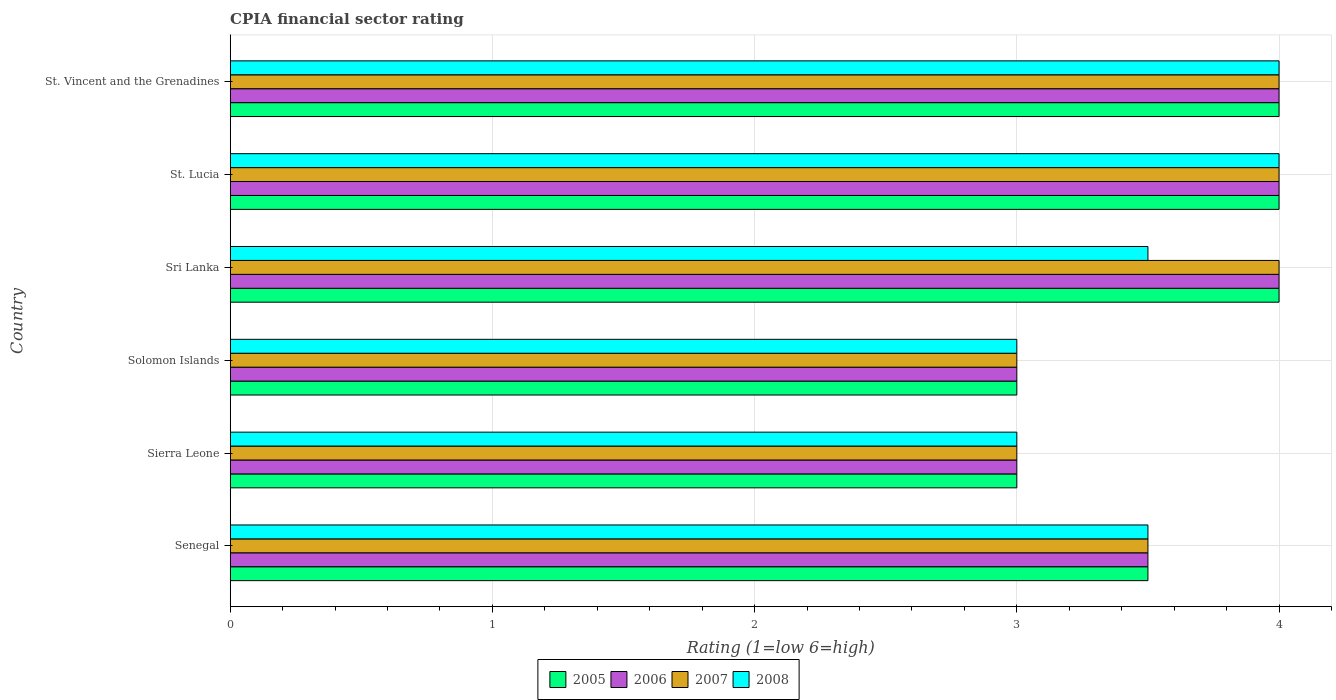How many different coloured bars are there?
Your answer should be very brief. 4. Are the number of bars per tick equal to the number of legend labels?
Ensure brevity in your answer.  Yes. What is the label of the 2nd group of bars from the top?
Provide a short and direct response. St. Lucia. Across all countries, what is the minimum CPIA rating in 2005?
Your response must be concise. 3. In which country was the CPIA rating in 2008 maximum?
Make the answer very short. St. Lucia. In which country was the CPIA rating in 2007 minimum?
Provide a short and direct response. Sierra Leone. What is the total CPIA rating in 2007 in the graph?
Ensure brevity in your answer.  21.5. What is the difference between the CPIA rating in 2007 in Sierra Leone and that in Sri Lanka?
Provide a short and direct response. -1. What is the average CPIA rating in 2008 per country?
Your answer should be very brief. 3.5. What is the difference between the highest and the lowest CPIA rating in 2005?
Your response must be concise. 1. In how many countries, is the CPIA rating in 2007 greater than the average CPIA rating in 2007 taken over all countries?
Provide a succinct answer. 3. What does the 2nd bar from the top in Sri Lanka represents?
Give a very brief answer. 2007. Are all the bars in the graph horizontal?
Your answer should be very brief. Yes. Are the values on the major ticks of X-axis written in scientific E-notation?
Make the answer very short. No. Does the graph contain grids?
Your answer should be very brief. Yes. How many legend labels are there?
Ensure brevity in your answer.  4. How are the legend labels stacked?
Your answer should be compact. Horizontal. What is the title of the graph?
Provide a succinct answer. CPIA financial sector rating. Does "1972" appear as one of the legend labels in the graph?
Your response must be concise. No. What is the label or title of the X-axis?
Provide a succinct answer. Rating (1=low 6=high). What is the label or title of the Y-axis?
Keep it short and to the point. Country. What is the Rating (1=low 6=high) in 2005 in Sierra Leone?
Make the answer very short. 3. What is the Rating (1=low 6=high) in 2007 in Sierra Leone?
Give a very brief answer. 3. What is the Rating (1=low 6=high) in 2008 in Sierra Leone?
Keep it short and to the point. 3. What is the Rating (1=low 6=high) in 2005 in Solomon Islands?
Make the answer very short. 3. What is the Rating (1=low 6=high) of 2005 in Sri Lanka?
Provide a short and direct response. 4. What is the Rating (1=low 6=high) in 2006 in Sri Lanka?
Provide a succinct answer. 4. What is the Rating (1=low 6=high) in 2007 in Sri Lanka?
Keep it short and to the point. 4. What is the Rating (1=low 6=high) of 2006 in St. Lucia?
Your answer should be compact. 4. What is the Rating (1=low 6=high) of 2005 in St. Vincent and the Grenadines?
Keep it short and to the point. 4. What is the Rating (1=low 6=high) in 2006 in St. Vincent and the Grenadines?
Keep it short and to the point. 4. What is the Rating (1=low 6=high) in 2008 in St. Vincent and the Grenadines?
Offer a very short reply. 4. Across all countries, what is the maximum Rating (1=low 6=high) of 2005?
Give a very brief answer. 4. Across all countries, what is the maximum Rating (1=low 6=high) in 2006?
Your response must be concise. 4. Across all countries, what is the maximum Rating (1=low 6=high) of 2007?
Your answer should be compact. 4. Across all countries, what is the minimum Rating (1=low 6=high) in 2006?
Your response must be concise. 3. What is the total Rating (1=low 6=high) of 2006 in the graph?
Give a very brief answer. 21.5. What is the total Rating (1=low 6=high) of 2007 in the graph?
Ensure brevity in your answer.  21.5. What is the difference between the Rating (1=low 6=high) in 2005 in Senegal and that in Solomon Islands?
Make the answer very short. 0.5. What is the difference between the Rating (1=low 6=high) in 2007 in Senegal and that in Solomon Islands?
Your answer should be compact. 0.5. What is the difference between the Rating (1=low 6=high) in 2008 in Senegal and that in Solomon Islands?
Make the answer very short. 0.5. What is the difference between the Rating (1=low 6=high) of 2005 in Senegal and that in Sri Lanka?
Offer a very short reply. -0.5. What is the difference between the Rating (1=low 6=high) of 2007 in Senegal and that in Sri Lanka?
Give a very brief answer. -0.5. What is the difference between the Rating (1=low 6=high) of 2005 in Senegal and that in St. Lucia?
Offer a terse response. -0.5. What is the difference between the Rating (1=low 6=high) in 2007 in Senegal and that in St. Lucia?
Make the answer very short. -0.5. What is the difference between the Rating (1=low 6=high) in 2008 in Senegal and that in St. Lucia?
Provide a short and direct response. -0.5. What is the difference between the Rating (1=low 6=high) in 2005 in Sierra Leone and that in Solomon Islands?
Offer a very short reply. 0. What is the difference between the Rating (1=low 6=high) in 2006 in Sierra Leone and that in Solomon Islands?
Provide a short and direct response. 0. What is the difference between the Rating (1=low 6=high) of 2007 in Sierra Leone and that in Solomon Islands?
Keep it short and to the point. 0. What is the difference between the Rating (1=low 6=high) in 2005 in Sierra Leone and that in Sri Lanka?
Keep it short and to the point. -1. What is the difference between the Rating (1=low 6=high) in 2006 in Sierra Leone and that in Sri Lanka?
Your answer should be compact. -1. What is the difference between the Rating (1=low 6=high) in 2007 in Sierra Leone and that in Sri Lanka?
Your response must be concise. -1. What is the difference between the Rating (1=low 6=high) in 2008 in Sierra Leone and that in Sri Lanka?
Your response must be concise. -0.5. What is the difference between the Rating (1=low 6=high) in 2005 in Sierra Leone and that in St. Vincent and the Grenadines?
Ensure brevity in your answer.  -1. What is the difference between the Rating (1=low 6=high) in 2007 in Sierra Leone and that in St. Vincent and the Grenadines?
Offer a very short reply. -1. What is the difference between the Rating (1=low 6=high) of 2005 in Solomon Islands and that in Sri Lanka?
Keep it short and to the point. -1. What is the difference between the Rating (1=low 6=high) of 2008 in Solomon Islands and that in Sri Lanka?
Offer a terse response. -0.5. What is the difference between the Rating (1=low 6=high) in 2005 in Solomon Islands and that in St. Lucia?
Your answer should be compact. -1. What is the difference between the Rating (1=low 6=high) of 2007 in Solomon Islands and that in St. Lucia?
Keep it short and to the point. -1. What is the difference between the Rating (1=low 6=high) in 2008 in Solomon Islands and that in St. Lucia?
Your response must be concise. -1. What is the difference between the Rating (1=low 6=high) of 2008 in Sri Lanka and that in St. Lucia?
Give a very brief answer. -0.5. What is the difference between the Rating (1=low 6=high) in 2006 in Sri Lanka and that in St. Vincent and the Grenadines?
Provide a short and direct response. 0. What is the difference between the Rating (1=low 6=high) in 2005 in St. Lucia and that in St. Vincent and the Grenadines?
Ensure brevity in your answer.  0. What is the difference between the Rating (1=low 6=high) in 2008 in St. Lucia and that in St. Vincent and the Grenadines?
Your response must be concise. 0. What is the difference between the Rating (1=low 6=high) in 2005 in Senegal and the Rating (1=low 6=high) in 2007 in Sierra Leone?
Provide a short and direct response. 0.5. What is the difference between the Rating (1=low 6=high) in 2006 in Senegal and the Rating (1=low 6=high) in 2007 in Sierra Leone?
Your response must be concise. 0.5. What is the difference between the Rating (1=low 6=high) of 2007 in Senegal and the Rating (1=low 6=high) of 2008 in Sierra Leone?
Your answer should be compact. 0.5. What is the difference between the Rating (1=low 6=high) in 2005 in Senegal and the Rating (1=low 6=high) in 2008 in Solomon Islands?
Your response must be concise. 0.5. What is the difference between the Rating (1=low 6=high) of 2007 in Senegal and the Rating (1=low 6=high) of 2008 in Solomon Islands?
Keep it short and to the point. 0.5. What is the difference between the Rating (1=low 6=high) in 2005 in Senegal and the Rating (1=low 6=high) in 2006 in St. Lucia?
Offer a terse response. -0.5. What is the difference between the Rating (1=low 6=high) of 2005 in Senegal and the Rating (1=low 6=high) of 2008 in St. Lucia?
Offer a very short reply. -0.5. What is the difference between the Rating (1=low 6=high) in 2006 in Senegal and the Rating (1=low 6=high) in 2008 in St. Lucia?
Provide a short and direct response. -0.5. What is the difference between the Rating (1=low 6=high) in 2007 in Senegal and the Rating (1=low 6=high) in 2008 in St. Lucia?
Offer a terse response. -0.5. What is the difference between the Rating (1=low 6=high) in 2005 in Senegal and the Rating (1=low 6=high) in 2006 in St. Vincent and the Grenadines?
Keep it short and to the point. -0.5. What is the difference between the Rating (1=low 6=high) of 2005 in Senegal and the Rating (1=low 6=high) of 2007 in St. Vincent and the Grenadines?
Your response must be concise. -0.5. What is the difference between the Rating (1=low 6=high) of 2005 in Senegal and the Rating (1=low 6=high) of 2008 in St. Vincent and the Grenadines?
Your response must be concise. -0.5. What is the difference between the Rating (1=low 6=high) of 2006 in Senegal and the Rating (1=low 6=high) of 2007 in St. Vincent and the Grenadines?
Provide a short and direct response. -0.5. What is the difference between the Rating (1=low 6=high) in 2006 in Senegal and the Rating (1=low 6=high) in 2008 in St. Vincent and the Grenadines?
Your response must be concise. -0.5. What is the difference between the Rating (1=low 6=high) in 2007 in Senegal and the Rating (1=low 6=high) in 2008 in St. Vincent and the Grenadines?
Provide a short and direct response. -0.5. What is the difference between the Rating (1=low 6=high) in 2007 in Sierra Leone and the Rating (1=low 6=high) in 2008 in Solomon Islands?
Give a very brief answer. 0. What is the difference between the Rating (1=low 6=high) in 2005 in Sierra Leone and the Rating (1=low 6=high) in 2007 in Sri Lanka?
Provide a succinct answer. -1. What is the difference between the Rating (1=low 6=high) of 2006 in Sierra Leone and the Rating (1=low 6=high) of 2007 in Sri Lanka?
Keep it short and to the point. -1. What is the difference between the Rating (1=low 6=high) in 2006 in Sierra Leone and the Rating (1=low 6=high) in 2008 in Sri Lanka?
Keep it short and to the point. -0.5. What is the difference between the Rating (1=low 6=high) of 2007 in Sierra Leone and the Rating (1=low 6=high) of 2008 in Sri Lanka?
Give a very brief answer. -0.5. What is the difference between the Rating (1=low 6=high) in 2006 in Sierra Leone and the Rating (1=low 6=high) in 2007 in St. Lucia?
Your answer should be compact. -1. What is the difference between the Rating (1=low 6=high) of 2006 in Sierra Leone and the Rating (1=low 6=high) of 2008 in St. Lucia?
Ensure brevity in your answer.  -1. What is the difference between the Rating (1=low 6=high) of 2007 in Sierra Leone and the Rating (1=low 6=high) of 2008 in St. Lucia?
Offer a very short reply. -1. What is the difference between the Rating (1=low 6=high) in 2006 in Sierra Leone and the Rating (1=low 6=high) in 2007 in St. Vincent and the Grenadines?
Keep it short and to the point. -1. What is the difference between the Rating (1=low 6=high) in 2006 in Sierra Leone and the Rating (1=low 6=high) in 2008 in St. Vincent and the Grenadines?
Your answer should be very brief. -1. What is the difference between the Rating (1=low 6=high) of 2005 in Solomon Islands and the Rating (1=low 6=high) of 2007 in Sri Lanka?
Make the answer very short. -1. What is the difference between the Rating (1=low 6=high) of 2005 in Solomon Islands and the Rating (1=low 6=high) of 2008 in Sri Lanka?
Offer a terse response. -0.5. What is the difference between the Rating (1=low 6=high) in 2006 in Solomon Islands and the Rating (1=low 6=high) in 2007 in Sri Lanka?
Keep it short and to the point. -1. What is the difference between the Rating (1=low 6=high) of 2007 in Solomon Islands and the Rating (1=low 6=high) of 2008 in Sri Lanka?
Offer a terse response. -0.5. What is the difference between the Rating (1=low 6=high) of 2006 in Solomon Islands and the Rating (1=low 6=high) of 2007 in St. Lucia?
Keep it short and to the point. -1. What is the difference between the Rating (1=low 6=high) of 2007 in Solomon Islands and the Rating (1=low 6=high) of 2008 in St. Lucia?
Your answer should be compact. -1. What is the difference between the Rating (1=low 6=high) of 2005 in Solomon Islands and the Rating (1=low 6=high) of 2006 in St. Vincent and the Grenadines?
Your answer should be compact. -1. What is the difference between the Rating (1=low 6=high) of 2005 in Solomon Islands and the Rating (1=low 6=high) of 2007 in St. Vincent and the Grenadines?
Give a very brief answer. -1. What is the difference between the Rating (1=low 6=high) of 2006 in Solomon Islands and the Rating (1=low 6=high) of 2008 in St. Vincent and the Grenadines?
Provide a short and direct response. -1. What is the difference between the Rating (1=low 6=high) in 2005 in Sri Lanka and the Rating (1=low 6=high) in 2006 in St. Lucia?
Your answer should be very brief. 0. What is the difference between the Rating (1=low 6=high) of 2006 in Sri Lanka and the Rating (1=low 6=high) of 2007 in St. Lucia?
Ensure brevity in your answer.  0. What is the difference between the Rating (1=low 6=high) of 2005 in Sri Lanka and the Rating (1=low 6=high) of 2006 in St. Vincent and the Grenadines?
Keep it short and to the point. 0. What is the difference between the Rating (1=low 6=high) in 2005 in Sri Lanka and the Rating (1=low 6=high) in 2008 in St. Vincent and the Grenadines?
Keep it short and to the point. 0. What is the difference between the Rating (1=low 6=high) in 2006 in Sri Lanka and the Rating (1=low 6=high) in 2007 in St. Vincent and the Grenadines?
Offer a very short reply. 0. What is the difference between the Rating (1=low 6=high) in 2005 in St. Lucia and the Rating (1=low 6=high) in 2007 in St. Vincent and the Grenadines?
Your answer should be compact. 0. What is the difference between the Rating (1=low 6=high) in 2005 in St. Lucia and the Rating (1=low 6=high) in 2008 in St. Vincent and the Grenadines?
Give a very brief answer. 0. What is the difference between the Rating (1=low 6=high) in 2006 in St. Lucia and the Rating (1=low 6=high) in 2007 in St. Vincent and the Grenadines?
Offer a very short reply. 0. What is the average Rating (1=low 6=high) in 2005 per country?
Your response must be concise. 3.58. What is the average Rating (1=low 6=high) in 2006 per country?
Your answer should be compact. 3.58. What is the average Rating (1=low 6=high) in 2007 per country?
Provide a short and direct response. 3.58. What is the average Rating (1=low 6=high) of 2008 per country?
Keep it short and to the point. 3.5. What is the difference between the Rating (1=low 6=high) of 2005 and Rating (1=low 6=high) of 2006 in Senegal?
Provide a short and direct response. 0. What is the difference between the Rating (1=low 6=high) of 2005 and Rating (1=low 6=high) of 2008 in Senegal?
Give a very brief answer. 0. What is the difference between the Rating (1=low 6=high) of 2006 and Rating (1=low 6=high) of 2008 in Senegal?
Make the answer very short. 0. What is the difference between the Rating (1=low 6=high) in 2007 and Rating (1=low 6=high) in 2008 in Senegal?
Keep it short and to the point. 0. What is the difference between the Rating (1=low 6=high) in 2005 and Rating (1=low 6=high) in 2006 in Sierra Leone?
Provide a succinct answer. 0. What is the difference between the Rating (1=low 6=high) in 2006 and Rating (1=low 6=high) in 2008 in Sierra Leone?
Make the answer very short. 0. What is the difference between the Rating (1=low 6=high) in 2007 and Rating (1=low 6=high) in 2008 in Sierra Leone?
Give a very brief answer. 0. What is the difference between the Rating (1=low 6=high) of 2005 and Rating (1=low 6=high) of 2006 in Solomon Islands?
Offer a terse response. 0. What is the difference between the Rating (1=low 6=high) in 2006 and Rating (1=low 6=high) in 2007 in Solomon Islands?
Ensure brevity in your answer.  0. What is the difference between the Rating (1=low 6=high) of 2007 and Rating (1=low 6=high) of 2008 in Solomon Islands?
Your response must be concise. 0. What is the difference between the Rating (1=low 6=high) in 2005 and Rating (1=low 6=high) in 2008 in Sri Lanka?
Provide a succinct answer. 0.5. What is the difference between the Rating (1=low 6=high) in 2006 and Rating (1=low 6=high) in 2008 in Sri Lanka?
Offer a terse response. 0.5. What is the difference between the Rating (1=low 6=high) of 2005 and Rating (1=low 6=high) of 2006 in St. Lucia?
Your response must be concise. 0. What is the difference between the Rating (1=low 6=high) in 2005 and Rating (1=low 6=high) in 2007 in St. Vincent and the Grenadines?
Provide a short and direct response. 0. What is the difference between the Rating (1=low 6=high) of 2005 and Rating (1=low 6=high) of 2008 in St. Vincent and the Grenadines?
Your response must be concise. 0. What is the ratio of the Rating (1=low 6=high) in 2006 in Senegal to that in Sierra Leone?
Provide a succinct answer. 1.17. What is the ratio of the Rating (1=low 6=high) in 2007 in Senegal to that in Sierra Leone?
Provide a short and direct response. 1.17. What is the ratio of the Rating (1=low 6=high) in 2008 in Senegal to that in Sierra Leone?
Provide a succinct answer. 1.17. What is the ratio of the Rating (1=low 6=high) in 2005 in Senegal to that in Solomon Islands?
Your response must be concise. 1.17. What is the ratio of the Rating (1=low 6=high) of 2006 in Senegal to that in Solomon Islands?
Keep it short and to the point. 1.17. What is the ratio of the Rating (1=low 6=high) in 2007 in Senegal to that in Solomon Islands?
Make the answer very short. 1.17. What is the ratio of the Rating (1=low 6=high) in 2008 in Senegal to that in Solomon Islands?
Provide a succinct answer. 1.17. What is the ratio of the Rating (1=low 6=high) in 2005 in Senegal to that in St. Lucia?
Keep it short and to the point. 0.88. What is the ratio of the Rating (1=low 6=high) of 2006 in Senegal to that in St. Lucia?
Keep it short and to the point. 0.88. What is the ratio of the Rating (1=low 6=high) in 2005 in Senegal to that in St. Vincent and the Grenadines?
Provide a succinct answer. 0.88. What is the ratio of the Rating (1=low 6=high) of 2007 in Senegal to that in St. Vincent and the Grenadines?
Your answer should be compact. 0.88. What is the ratio of the Rating (1=low 6=high) in 2005 in Sierra Leone to that in Solomon Islands?
Keep it short and to the point. 1. What is the ratio of the Rating (1=low 6=high) of 2005 in Sierra Leone to that in Sri Lanka?
Offer a very short reply. 0.75. What is the ratio of the Rating (1=low 6=high) in 2006 in Sierra Leone to that in Sri Lanka?
Offer a terse response. 0.75. What is the ratio of the Rating (1=low 6=high) of 2006 in Sierra Leone to that in St. Lucia?
Provide a succinct answer. 0.75. What is the ratio of the Rating (1=low 6=high) in 2007 in Sierra Leone to that in St. Lucia?
Provide a short and direct response. 0.75. What is the ratio of the Rating (1=low 6=high) of 2006 in Sierra Leone to that in St. Vincent and the Grenadines?
Provide a succinct answer. 0.75. What is the ratio of the Rating (1=low 6=high) of 2008 in Solomon Islands to that in Sri Lanka?
Offer a very short reply. 0.86. What is the ratio of the Rating (1=low 6=high) in 2008 in Solomon Islands to that in St. Lucia?
Your answer should be very brief. 0.75. What is the ratio of the Rating (1=low 6=high) of 2005 in Solomon Islands to that in St. Vincent and the Grenadines?
Provide a short and direct response. 0.75. What is the ratio of the Rating (1=low 6=high) of 2008 in Solomon Islands to that in St. Vincent and the Grenadines?
Make the answer very short. 0.75. What is the ratio of the Rating (1=low 6=high) in 2006 in Sri Lanka to that in St. Lucia?
Offer a very short reply. 1. What is the ratio of the Rating (1=low 6=high) of 2005 in Sri Lanka to that in St. Vincent and the Grenadines?
Offer a terse response. 1. What is the ratio of the Rating (1=low 6=high) of 2006 in Sri Lanka to that in St. Vincent and the Grenadines?
Give a very brief answer. 1. What is the ratio of the Rating (1=low 6=high) in 2007 in Sri Lanka to that in St. Vincent and the Grenadines?
Make the answer very short. 1. What is the ratio of the Rating (1=low 6=high) of 2008 in Sri Lanka to that in St. Vincent and the Grenadines?
Offer a terse response. 0.88. What is the ratio of the Rating (1=low 6=high) of 2006 in St. Lucia to that in St. Vincent and the Grenadines?
Make the answer very short. 1. What is the ratio of the Rating (1=low 6=high) in 2007 in St. Lucia to that in St. Vincent and the Grenadines?
Offer a terse response. 1. What is the ratio of the Rating (1=low 6=high) in 2008 in St. Lucia to that in St. Vincent and the Grenadines?
Your answer should be compact. 1. What is the difference between the highest and the second highest Rating (1=low 6=high) of 2007?
Your answer should be compact. 0. What is the difference between the highest and the lowest Rating (1=low 6=high) of 2005?
Your response must be concise. 1. What is the difference between the highest and the lowest Rating (1=low 6=high) of 2006?
Give a very brief answer. 1. What is the difference between the highest and the lowest Rating (1=low 6=high) in 2007?
Your answer should be compact. 1. 